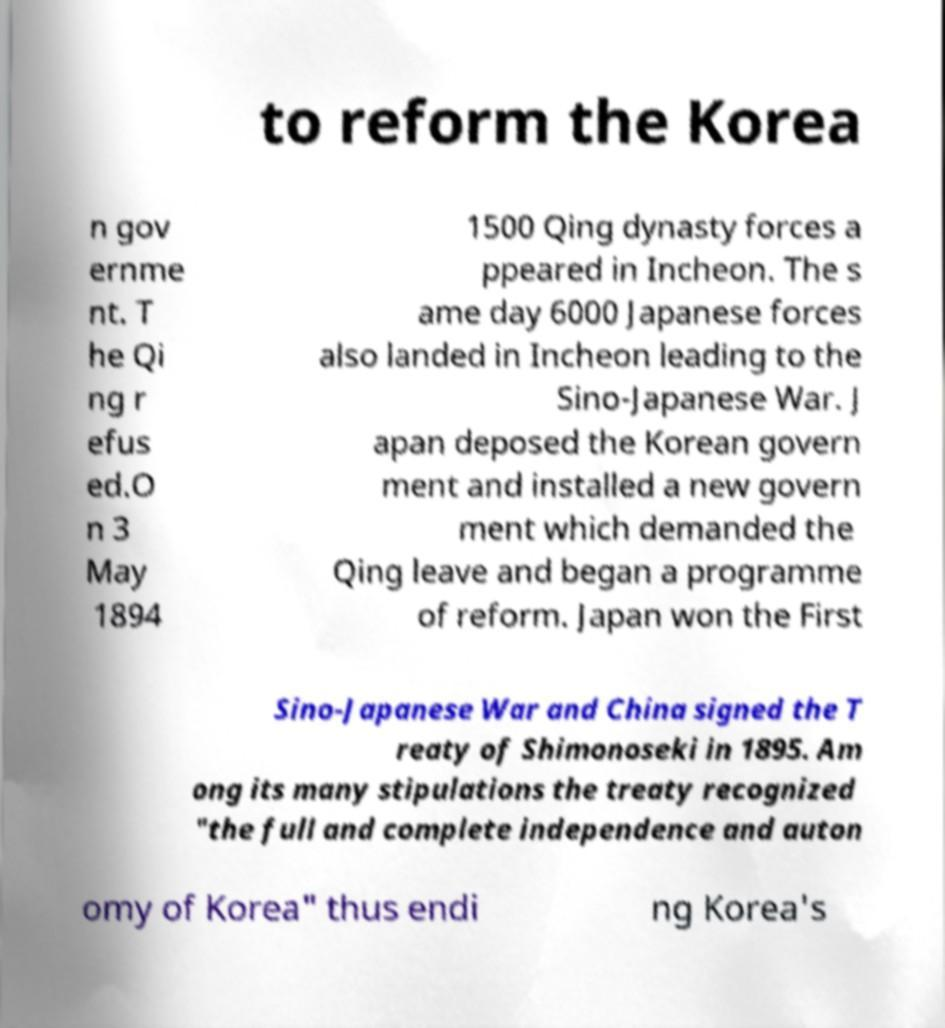What messages or text are displayed in this image? I need them in a readable, typed format. to reform the Korea n gov ernme nt. T he Qi ng r efus ed.O n 3 May 1894 1500 Qing dynasty forces a ppeared in Incheon. The s ame day 6000 Japanese forces also landed in Incheon leading to the Sino-Japanese War. J apan deposed the Korean govern ment and installed a new govern ment which demanded the Qing leave and began a programme of reform. Japan won the First Sino-Japanese War and China signed the T reaty of Shimonoseki in 1895. Am ong its many stipulations the treaty recognized "the full and complete independence and auton omy of Korea" thus endi ng Korea's 